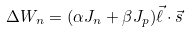Convert formula to latex. <formula><loc_0><loc_0><loc_500><loc_500>\Delta W _ { n } = ( \alpha J _ { n } + \beta J _ { p } ) \vec { \ell } \cdot \vec { s }</formula> 